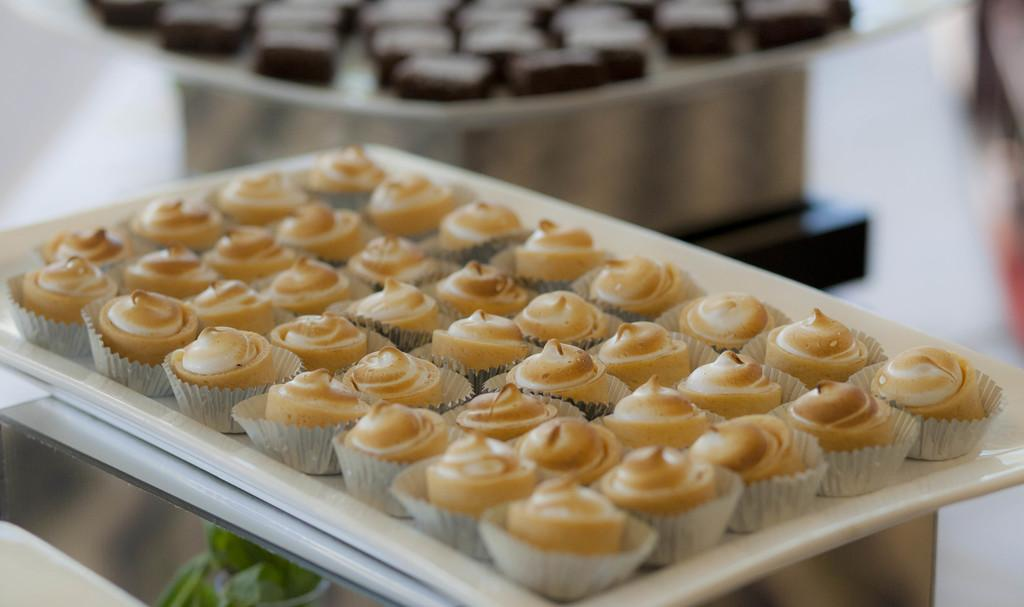What type of food items can be seen in the image? There are food items in the image, and they are kept in cupcake molds. Where are the food items placed? The food items are placed on a table. What do the food items have in common? All the food items are of the same category. Can you tell me how many cows are sleeping on the farm in the image? There are no cows or farms present in the image; it features food items in cupcake molds on a table. 